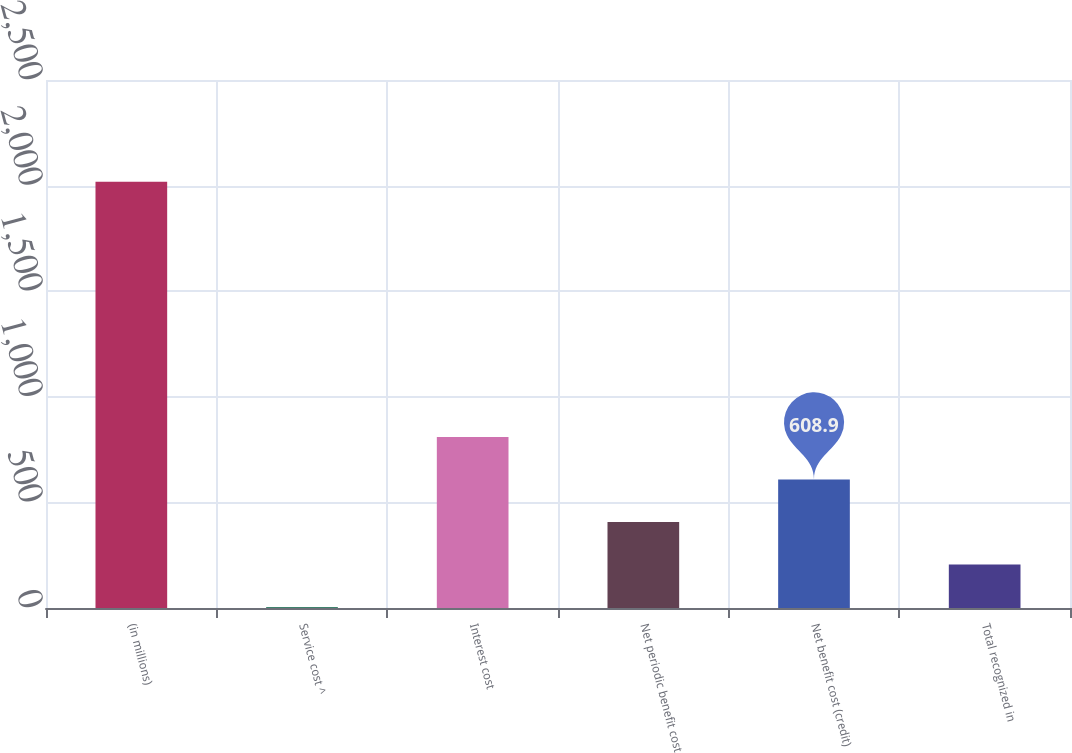Convert chart to OTSL. <chart><loc_0><loc_0><loc_500><loc_500><bar_chart><fcel>(in millions)<fcel>Service cost ^<fcel>Interest cost<fcel>Net periodic benefit cost<fcel>Net benefit cost (credit)<fcel>Total recognized in<nl><fcel>2018<fcel>5<fcel>810.2<fcel>407.6<fcel>608.9<fcel>206.3<nl></chart> 